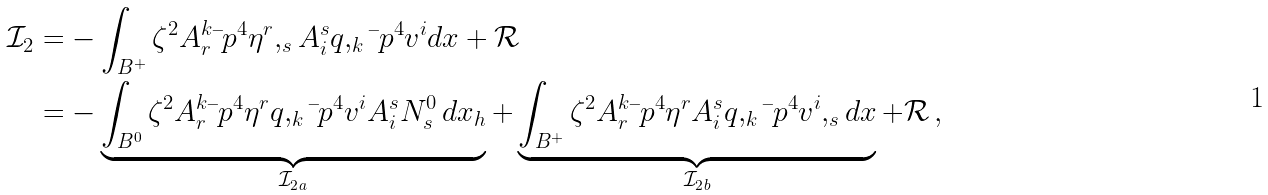<formula> <loc_0><loc_0><loc_500><loc_500>\mathcal { I } _ { 2 } & = - \int _ { B ^ { + } } \zeta ^ { 2 } A ^ { k } _ { r } \bar { \ } p ^ { 4 } \eta ^ { r } , _ { s } A ^ { s } _ { i } q , _ { k } \bar { \ } p ^ { 4 } v ^ { i } d x + \mathcal { R } \\ & = - \underbrace { \int _ { B ^ { 0 } } \zeta ^ { 2 } A ^ { k } _ { r } \bar { \ } p ^ { 4 } \eta ^ { r } q , _ { k } \bar { \ } p ^ { 4 } v ^ { i } A ^ { s } _ { i } N ^ { 0 } _ { s } \, d x _ { h } } _ { { \mathcal { I } _ { 2 } } _ { a } } + \underbrace { \int _ { B ^ { + } } \zeta ^ { 2 } A ^ { k } _ { r } \bar { \ } p ^ { 4 } \eta ^ { r } A ^ { s } _ { i } q , _ { k } \bar { \ } p ^ { 4 } v ^ { i } , _ { s } d x } _ { { \mathcal { I } _ { 2 } } _ { b } } + \mathcal { R } \, ,</formula> 